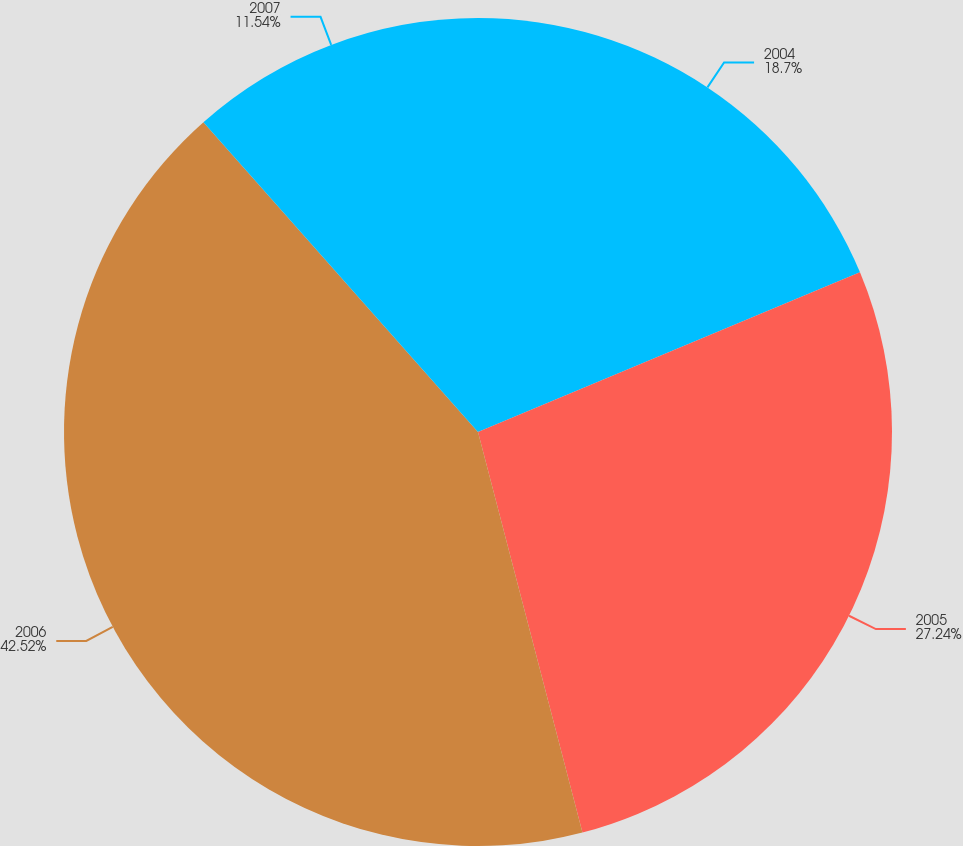<chart> <loc_0><loc_0><loc_500><loc_500><pie_chart><fcel>2004<fcel>2005<fcel>2006<fcel>2007<nl><fcel>18.7%<fcel>27.24%<fcel>42.52%<fcel>11.54%<nl></chart> 